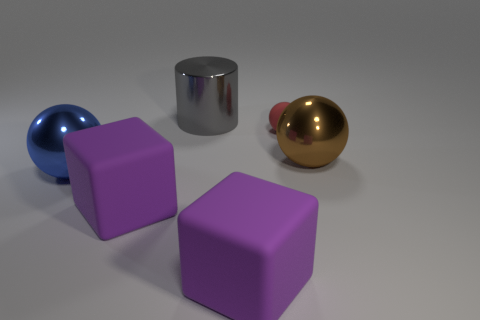Are there an equal number of big cylinders on the right side of the small rubber thing and large purple cubes?
Offer a very short reply. No. The large ball that is on the right side of the large metallic ball left of the matte thing behind the blue object is made of what material?
Provide a succinct answer. Metal. How many objects are big matte cubes that are to the left of the brown object or gray things?
Your response must be concise. 3. What number of objects are either small brown metallic cylinders or things to the right of the blue metallic thing?
Provide a short and direct response. 5. There is a shiny object that is behind the metallic ball that is behind the large blue shiny ball; what number of purple rubber objects are on the left side of it?
Make the answer very short. 1. What material is the cylinder that is the same size as the brown sphere?
Ensure brevity in your answer.  Metal. Are there any balls of the same size as the blue metal object?
Provide a short and direct response. Yes. The metal cylinder has what color?
Offer a terse response. Gray. The ball that is behind the metal ball right of the rubber ball is what color?
Ensure brevity in your answer.  Red. There is a matte thing behind the large blue metallic object to the left of the big thing that is behind the red matte sphere; what is its shape?
Provide a succinct answer. Sphere. 